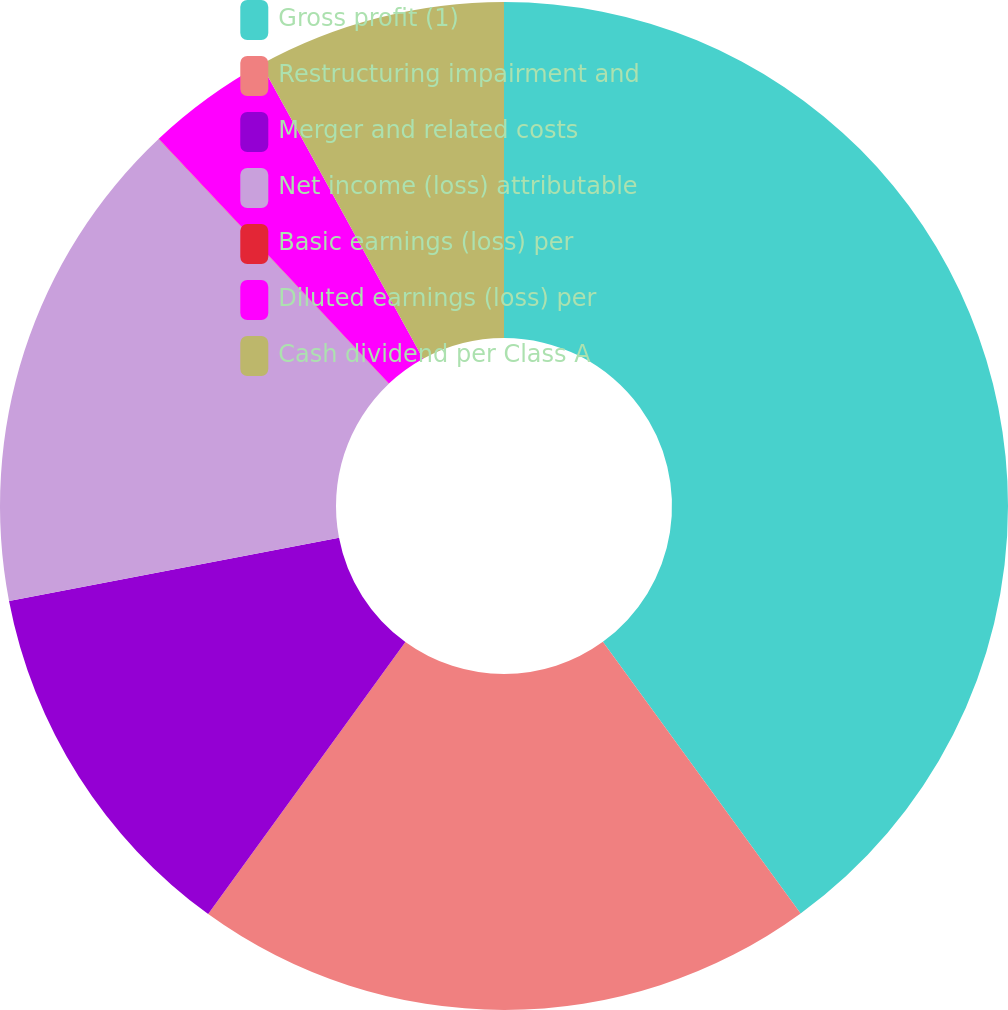Convert chart to OTSL. <chart><loc_0><loc_0><loc_500><loc_500><pie_chart><fcel>Gross profit (1)<fcel>Restructuring impairment and<fcel>Merger and related costs<fcel>Net income (loss) attributable<fcel>Basic earnings (loss) per<fcel>Diluted earnings (loss) per<fcel>Cash dividend per Class A<nl><fcel>39.99%<fcel>20.0%<fcel>12.0%<fcel>16.0%<fcel>0.01%<fcel>4.01%<fcel>8.0%<nl></chart> 